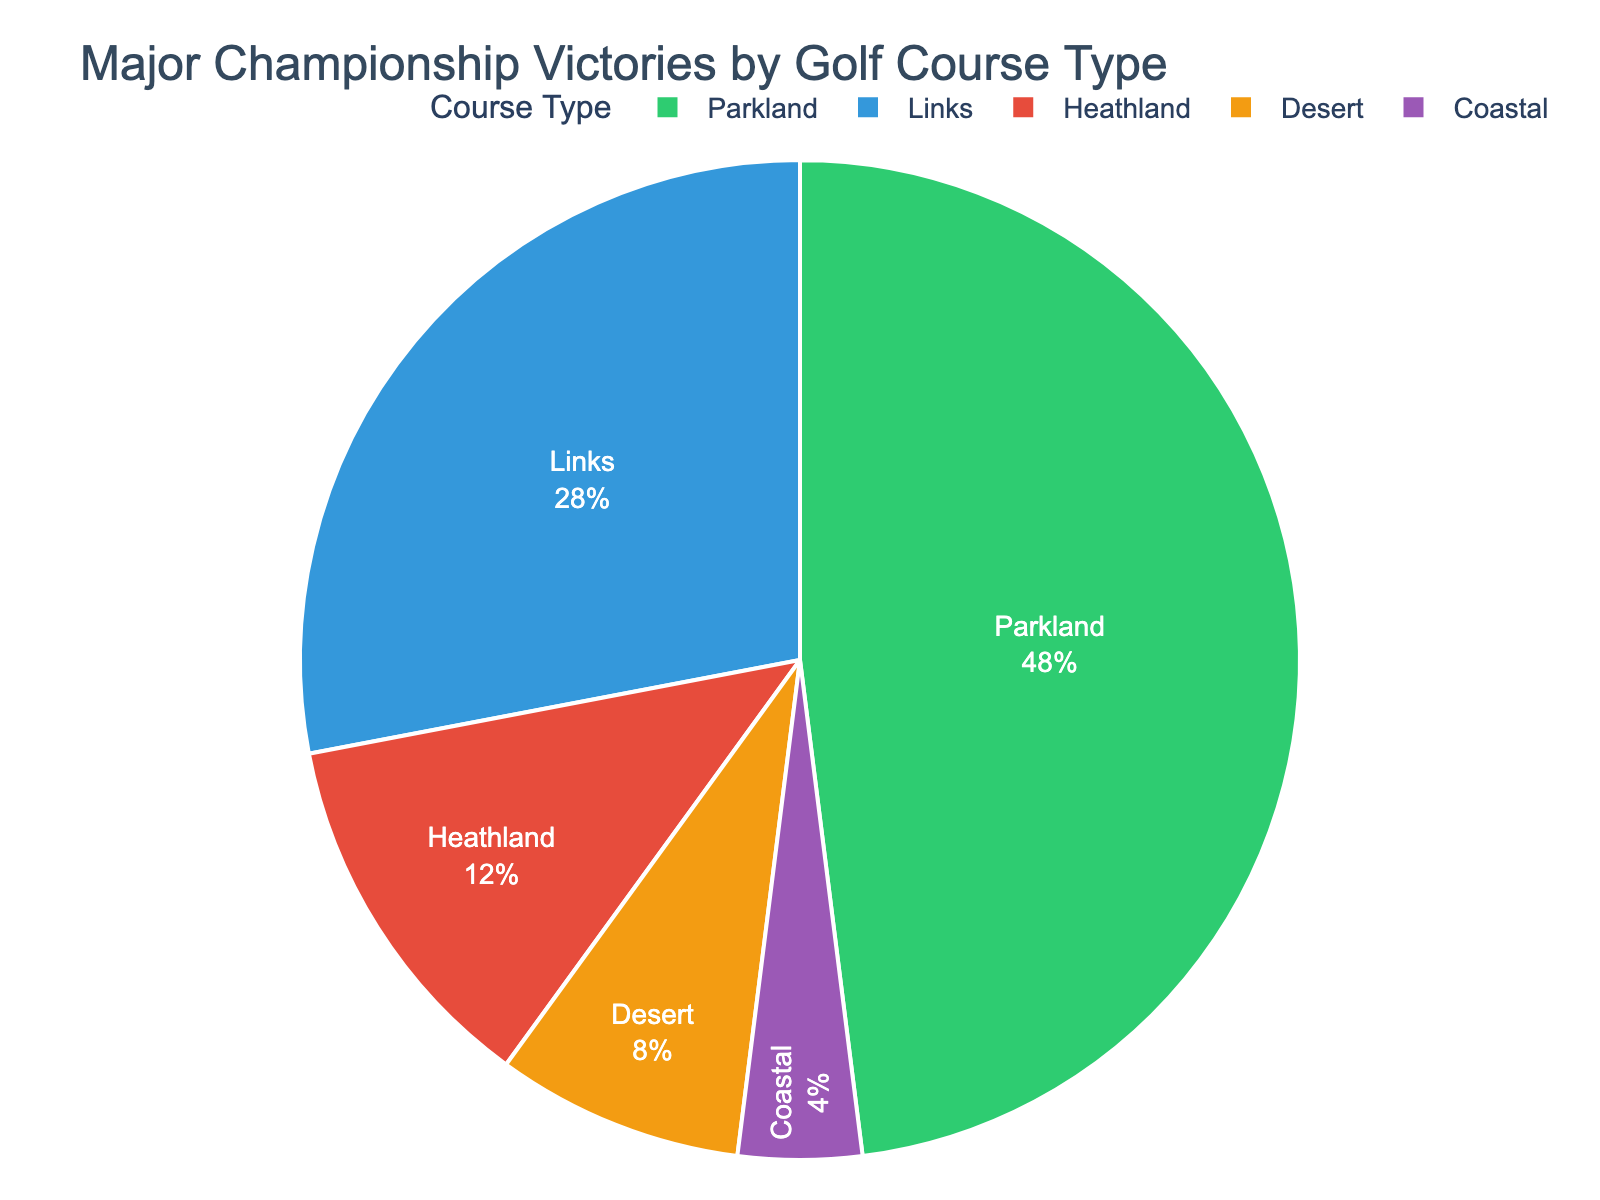Which golf course type has the highest number of major championship victories? The pie chart shows the number of victories for each course type. The segment labeled "Parkland" is the largest.
Answer: Parkland How many more major championship victories are there on parkland courses compared to links courses? According to the pie chart, Parkland courses have 12 victories while Links courses have 7 victories. Subtracting 7 from 12 gives the difference.
Answer: 5 What percentage of the major championship victories took place on desert courses? The segment labeled "Desert" represents 2 victories out of a total of 25 (sum of all victories). The percentage is calculated as (2/25) * 100.
Answer: 8% Are there more major championship victories on parkland courses or the combined total of links and desert courses? Parkland courses have 12 victories. Links and Desert courses combined have 7 + 2 = 9 victories. Since 12 is greater than 9, Parkland has more victories.
Answer: Parkland How does the number of victories on heathland courses compare to those on coastal courses? The pie chart shows 3 victories for Heathland courses and 1 victory for Coastal courses. Comparing the two, Heathland courses have more victories.
Answer: Heathland What is the total number of major championship victories depicted in the pie chart? Summing all the victories given in the pie chart: 7 (Links) + 12 (Parkland) + 2 (Desert) + 3 (Heathland) + 1 (Coastal) = 25
Answer: 25 What proportion of the total victories occurred on links courses? Links courses have 7 victories out of 25 total victories. The proportion is given by 7/25.
Answer: 28% By what fraction do the victories on parkland courses exceed those on heathland courses? Parkland courses have 12 victories, Heathland courses have 3. The fraction of the difference is (12 - 3) / 3.
Answer: 3 Which course type has the smallest share of major championship victories? The smallest segment in the pie chart is labeled "Coastal," which has 1 victory.
Answer: Coastal Among links, parkland, and desert courses, which type has the middle range number of victories? Comparing the victories: Links have 7, Parkland 12, and Desert 2. The middle value is Links with 7 victories.
Answer: Links 